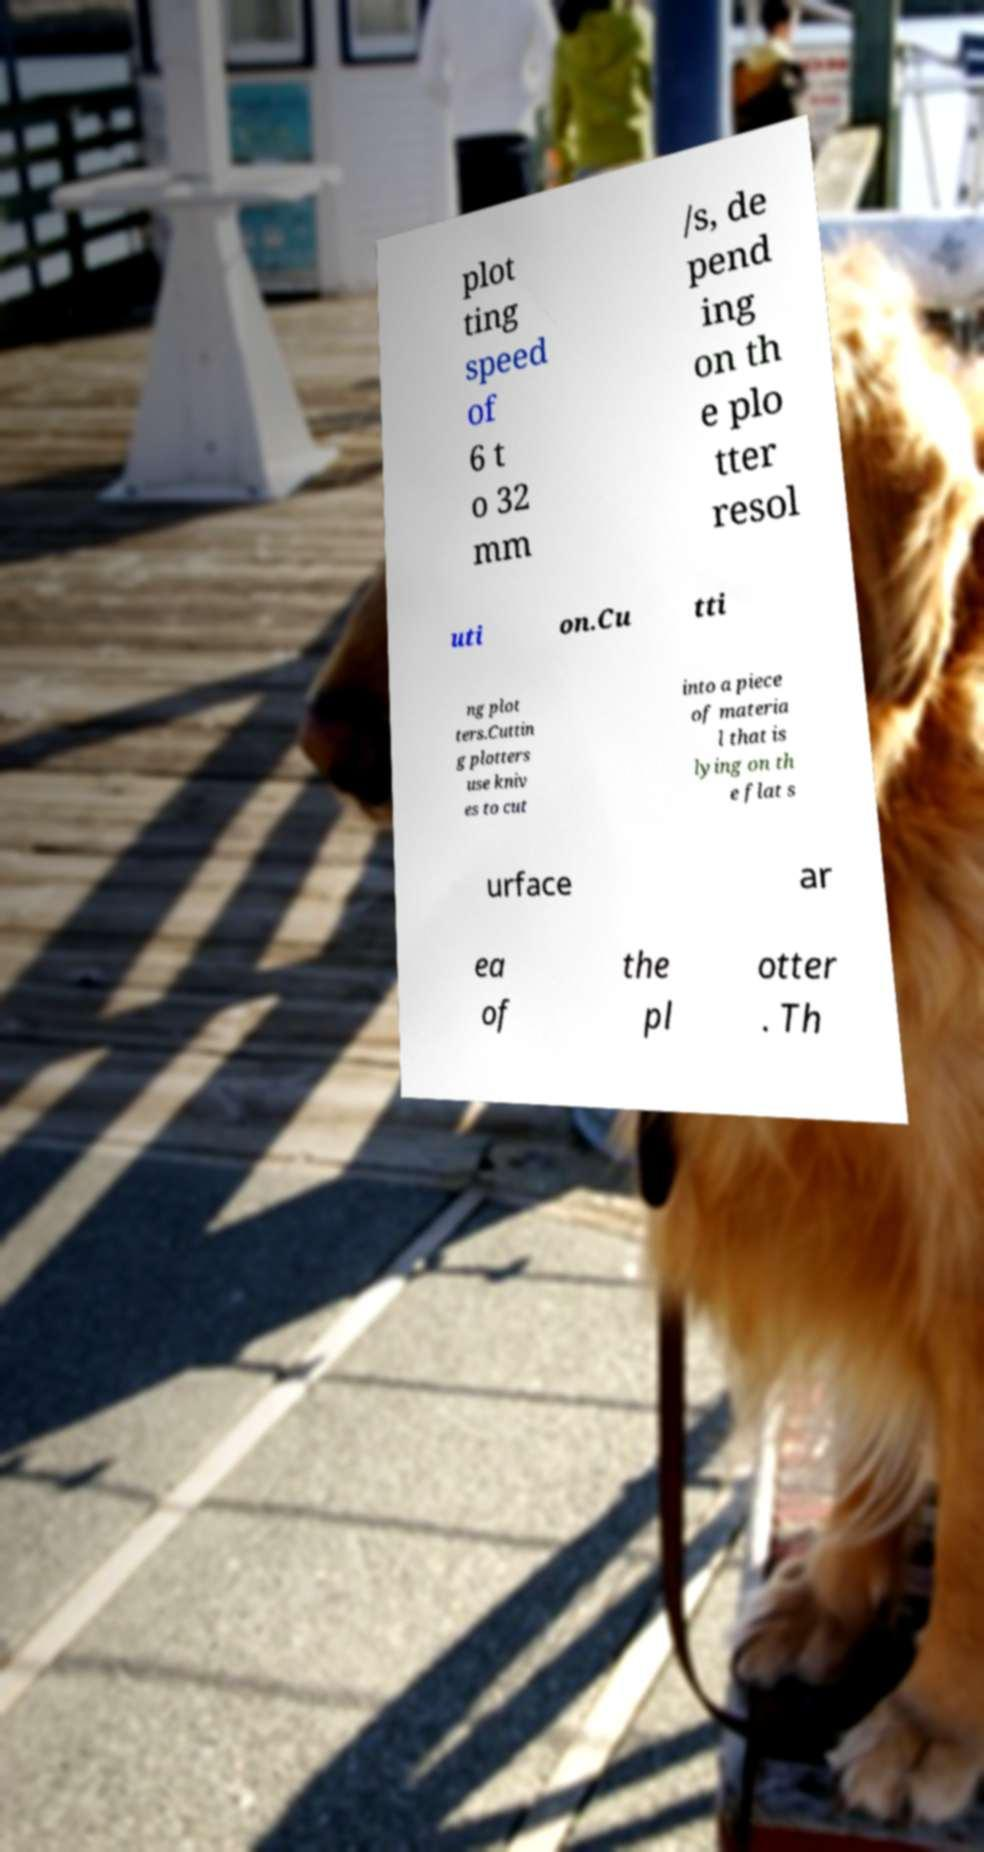Please identify and transcribe the text found in this image. plot ting speed of 6 t o 32 mm /s, de pend ing on th e plo tter resol uti on.Cu tti ng plot ters.Cuttin g plotters use kniv es to cut into a piece of materia l that is lying on th e flat s urface ar ea of the pl otter . Th 